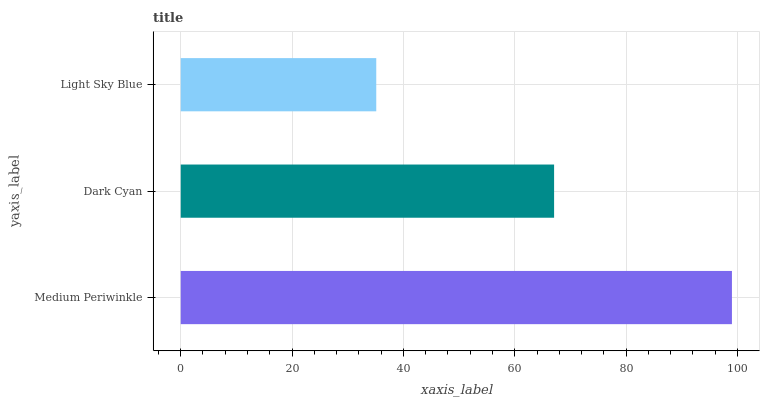Is Light Sky Blue the minimum?
Answer yes or no. Yes. Is Medium Periwinkle the maximum?
Answer yes or no. Yes. Is Dark Cyan the minimum?
Answer yes or no. No. Is Dark Cyan the maximum?
Answer yes or no. No. Is Medium Periwinkle greater than Dark Cyan?
Answer yes or no. Yes. Is Dark Cyan less than Medium Periwinkle?
Answer yes or no. Yes. Is Dark Cyan greater than Medium Periwinkle?
Answer yes or no. No. Is Medium Periwinkle less than Dark Cyan?
Answer yes or no. No. Is Dark Cyan the high median?
Answer yes or no. Yes. Is Dark Cyan the low median?
Answer yes or no. Yes. Is Medium Periwinkle the high median?
Answer yes or no. No. Is Light Sky Blue the low median?
Answer yes or no. No. 